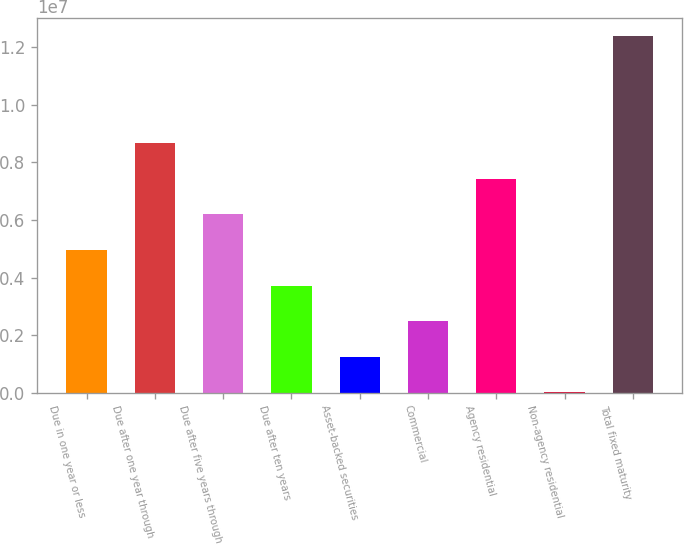Convert chart. <chart><loc_0><loc_0><loc_500><loc_500><bar_chart><fcel>Due in one year or less<fcel>Due after one year through<fcel>Due after five years through<fcel>Due after ten years<fcel>Asset-backed securities<fcel>Commercial<fcel>Agency residential<fcel>Non-agency residential<fcel>Total fixed maturity<nl><fcel>4.95936e+06<fcel>8.67526e+06<fcel>6.19799e+06<fcel>3.72072e+06<fcel>1.24345e+06<fcel>2.48209e+06<fcel>7.43662e+06<fcel>4816<fcel>1.23912e+07<nl></chart> 